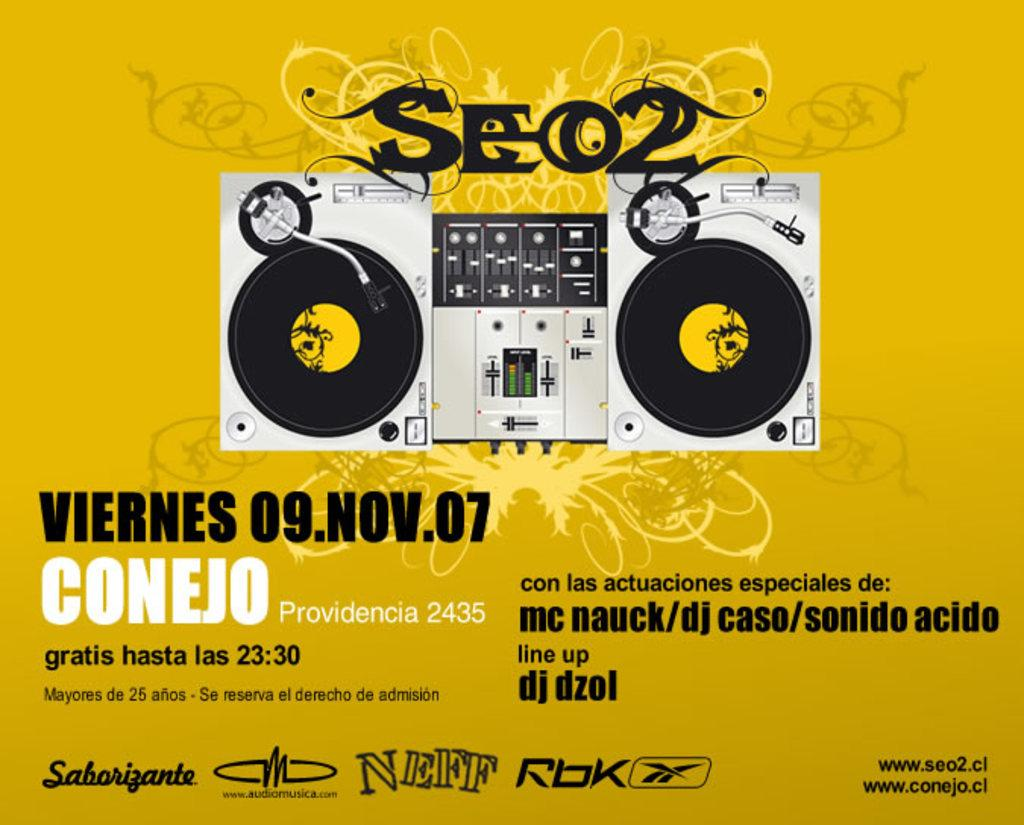<image>
Describe the image concisely. An advertisement for a music show says that dj dzol is part of the line up. 